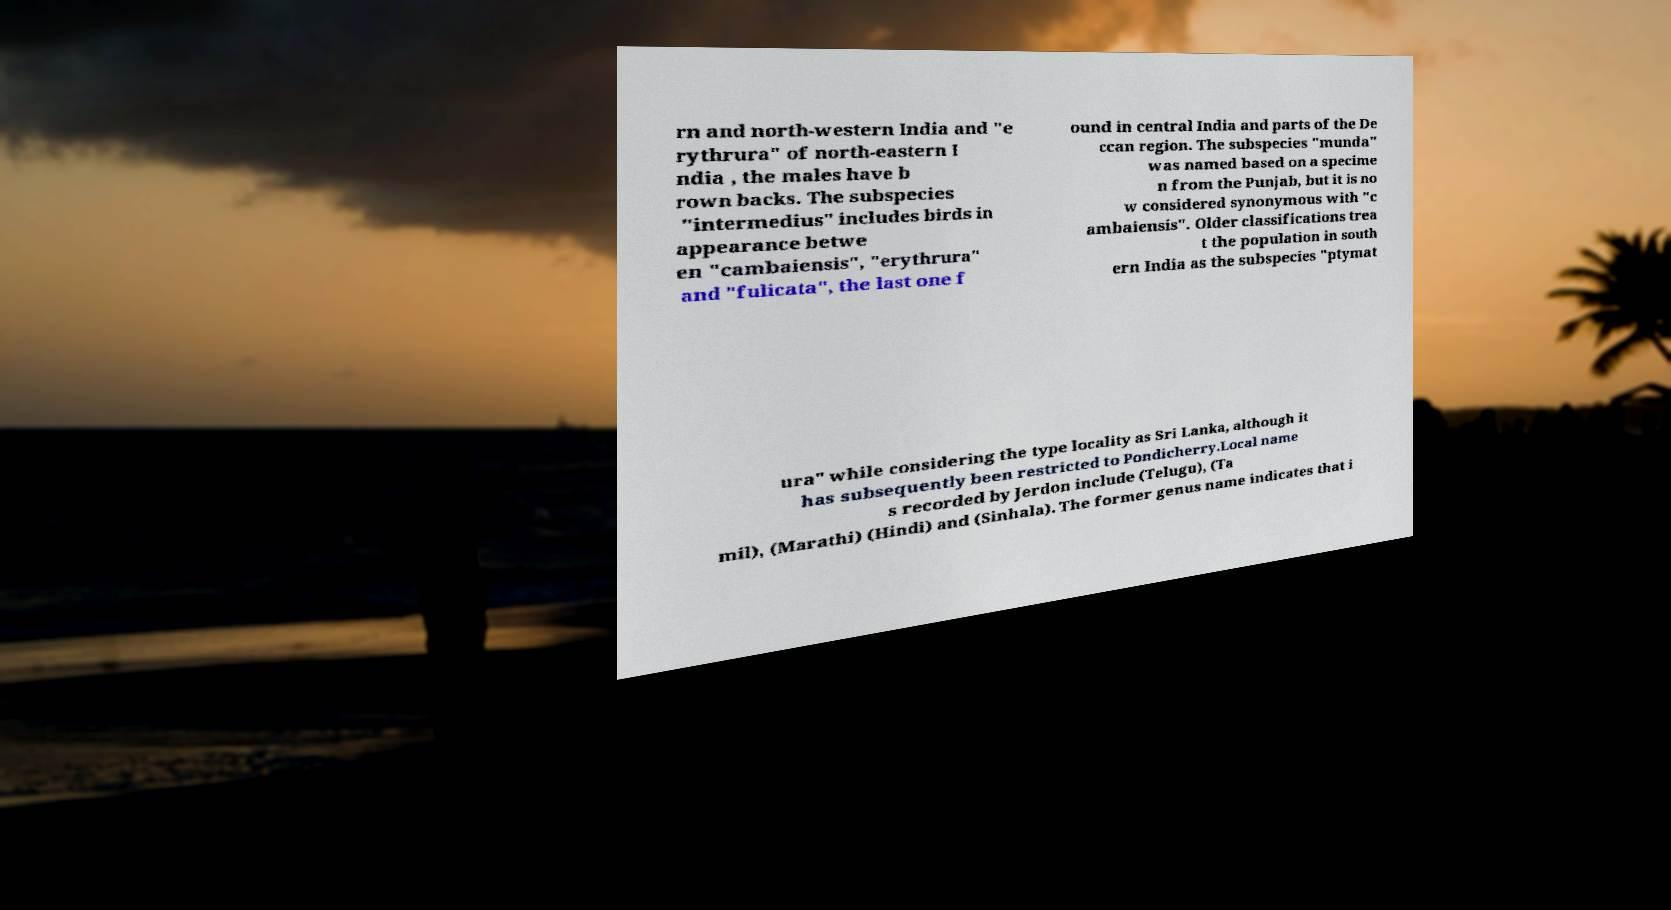Please read and relay the text visible in this image. What does it say? rn and north-western India and "e rythrura" of north-eastern I ndia , the males have b rown backs. The subspecies "intermedius" includes birds in appearance betwe en "cambaiensis", "erythrura" and "fulicata", the last one f ound in central India and parts of the De ccan region. The subspecies "munda" was named based on a specime n from the Punjab, but it is no w considered synonymous with "c ambaiensis". Older classifications trea t the population in south ern India as the subspecies "ptymat ura" while considering the type locality as Sri Lanka, although it has subsequently been restricted to Pondicherry.Local name s recorded by Jerdon include (Telugu), (Ta mil), (Marathi) (Hindi) and (Sinhala). The former genus name indicates that i 